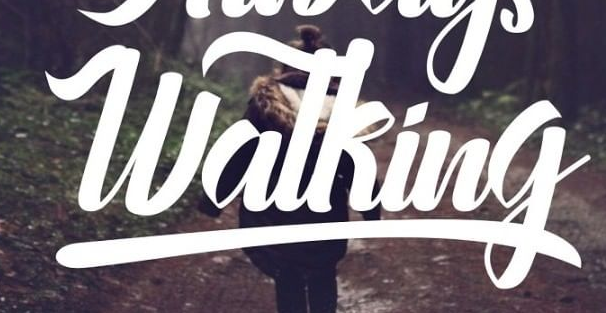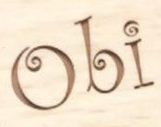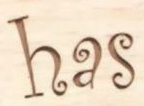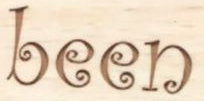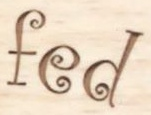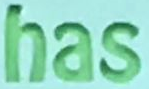Read the text content from these images in order, separated by a semicolon. Watking; Obi; has; been; fed; has 